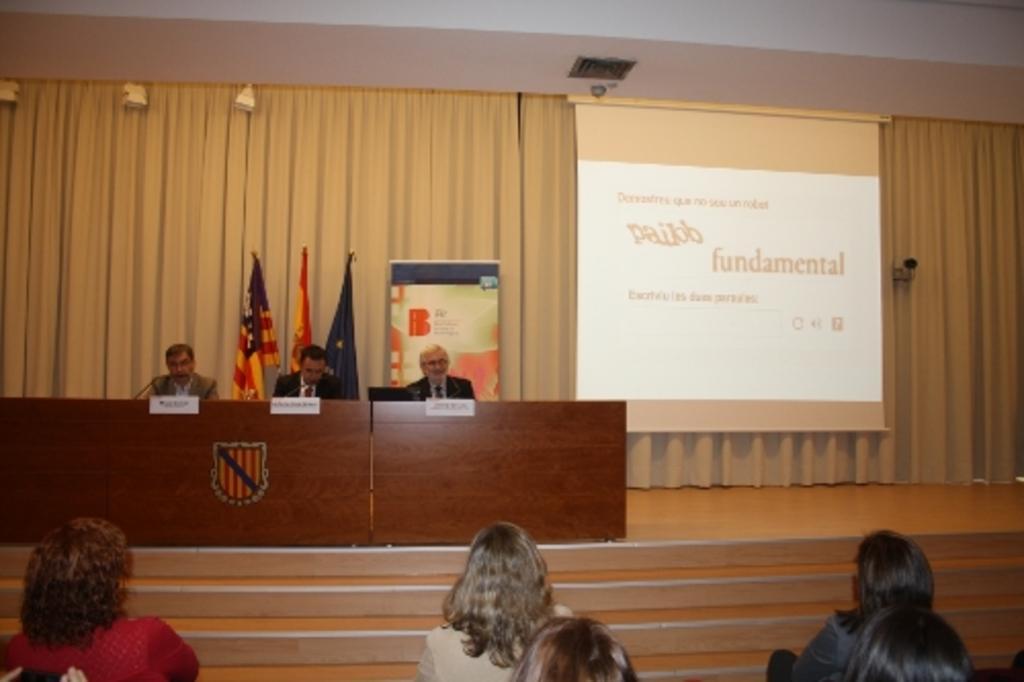Describe this image in one or two sentences. In this picture we can see three people on the stage, in front of them we can see mics, tables, name boards and few people and in the background we can see a projector screen, flags, curtain and some objects. 